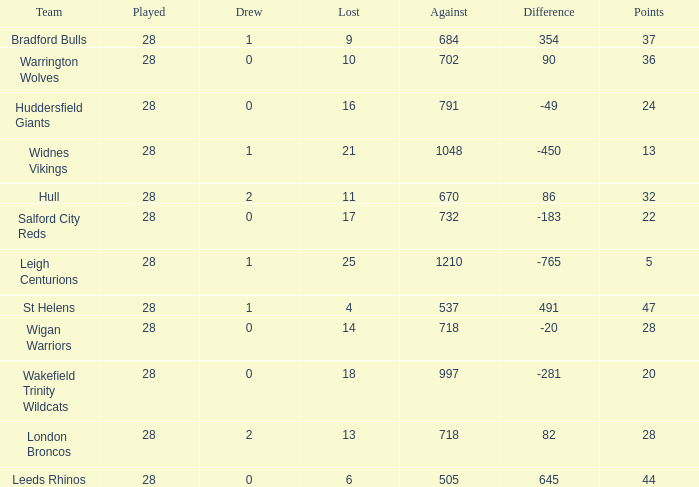What is the highest difference for the team that had less than 0 draws? None. 